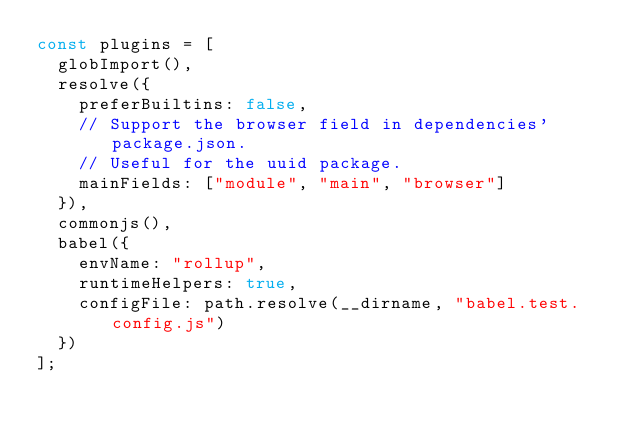Convert code to text. <code><loc_0><loc_0><loc_500><loc_500><_JavaScript_>const plugins = [
  globImport(),
  resolve({
    preferBuiltins: false,
    // Support the browser field in dependencies' package.json.
    // Useful for the uuid package.
    mainFields: ["module", "main", "browser"]
  }),
  commonjs(),
  babel({
    envName: "rollup",
    runtimeHelpers: true,
    configFile: path.resolve(__dirname, "babel.test.config.js")
  })
];
</code> 